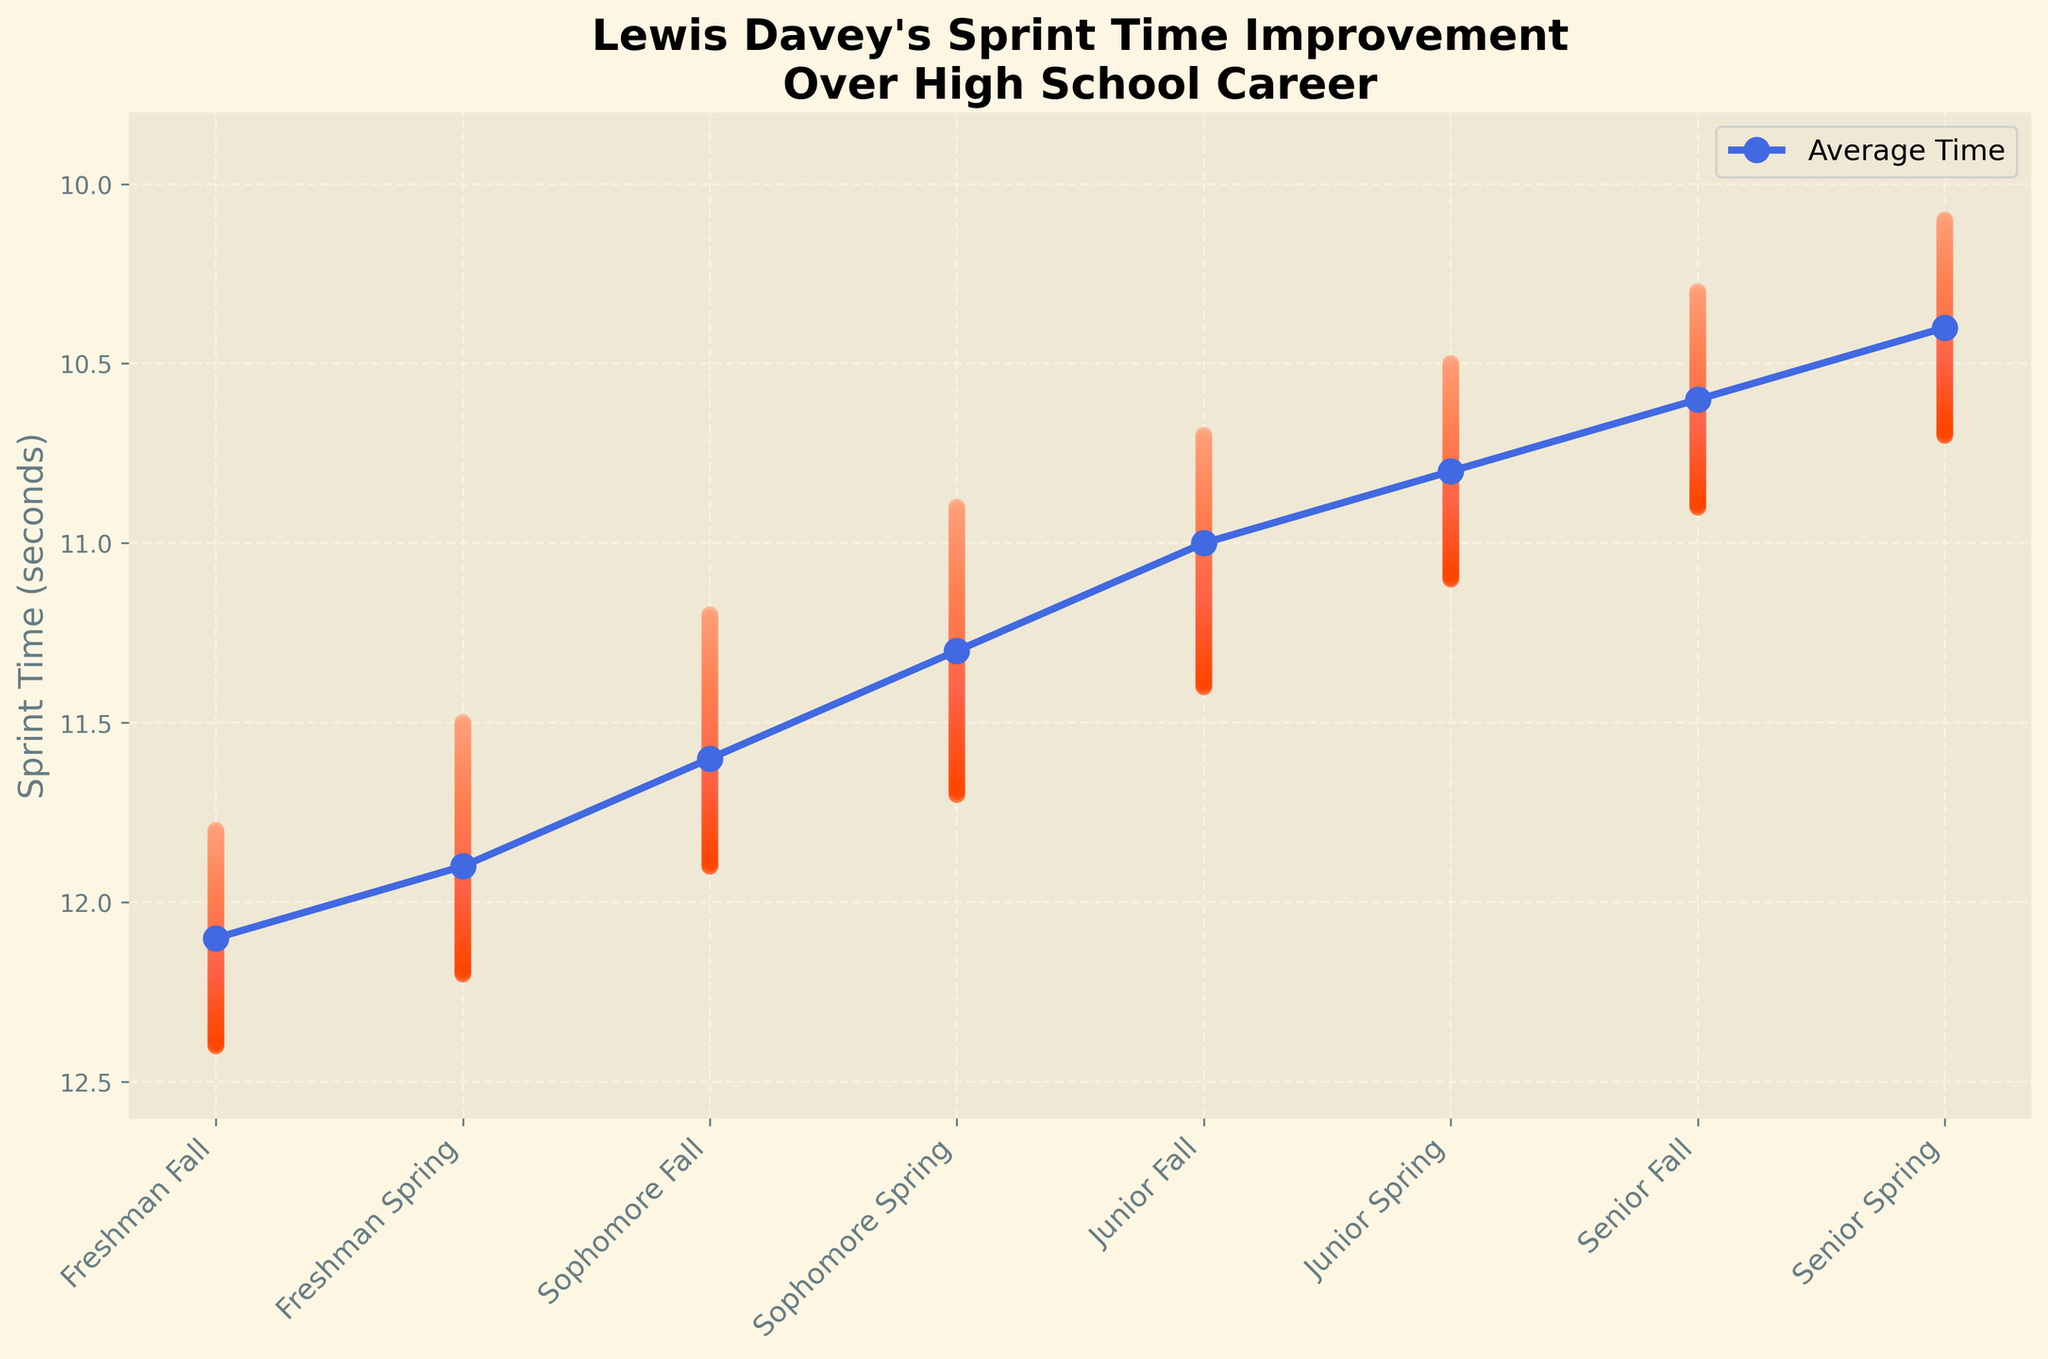What's the title of the figure? The title is generally located at the top of a plot, usually in a larger or bold font. The title for this plot is "Lewis Davey's Sprint Time Improvement\nOver High School Career".
Answer: Lewis Davey's Sprint Time Improvement Over High School Career What is the overall trend of the average sprint times from Freshman Fall to Senior Spring? Looking at the plotted average sprint times, you can observe that the times generally decrease from Freshman Fall to Senior Spring, indicating improvement in performance over time.
Answer: Decreasing trend What is the minimum sprint time achieved in Senior Spring? To find this, you look at the minimum value for the Senior Spring season in the plot. The minimum sprint time recorded is 10.1 seconds.
Answer: 10.1 seconds How does the range of sprint times change from Freshman Fall to Senior Spring? Compare the spread between the minimum and maximum sprint times for Freshman Fall and Senior Spring. Freshman Fall has a range from 11.8 to 12.4 seconds, while Senior Spring has a range from 10.1 to 10.7 seconds. The range narrows as the seasons progress.
Answer: Narrowing range In which season did Lewis Davey first run a sprint time under 11 seconds? By examining the minimum sprint times across seasons, the first instance under 11 seconds is Sophomore Spring with a time of 10.9 seconds.
Answer: Sophomore Spring How many seasons show an average sprint time below 11 seconds? Identify the seasons where the average sprint time drops below 11. These are Junior Fall, Junior Spring, Senior Fall, and Senior Spring, making it four seasons in total.
Answer: 4 seasons What's the reduction in average sprint time from Freshman Fall to Senior Spring? Subtract the average sprint time for Senior Spring from Freshman Fall: 12.1 - 10.4 = 1.7 seconds. This shows the overall improvement in average time.
Answer: 1.7 seconds Which season shows the most significant improvement in average sprint time compared to the previous season? Comparing the difference in average times between consecutive seasons, the biggest drop appears between Sophomore Fall and Sophomore Spring: 11.6 - 11.3 = 0.3 seconds.
Answer: Sophomore Spring Is there a season where the average sprint time is closer to the maximum sprint time than the minimum sprint time? To answer this, compare the difference between average and minimum times as well as average and maximum times across all seasons. For example, in Freshman Fall, average (12.1) is closer to maximum (12.4) than minimum (11.8), making it one such season.
Answer: Freshman Fall What colors are used to represent the fan chart in the figure? The colors in the fan chart range from lighter shades like salmon and coral to darker shades like tomato and orange-red, creating a gradient.
Answer: Salmon, coral, tomato, orange-red 